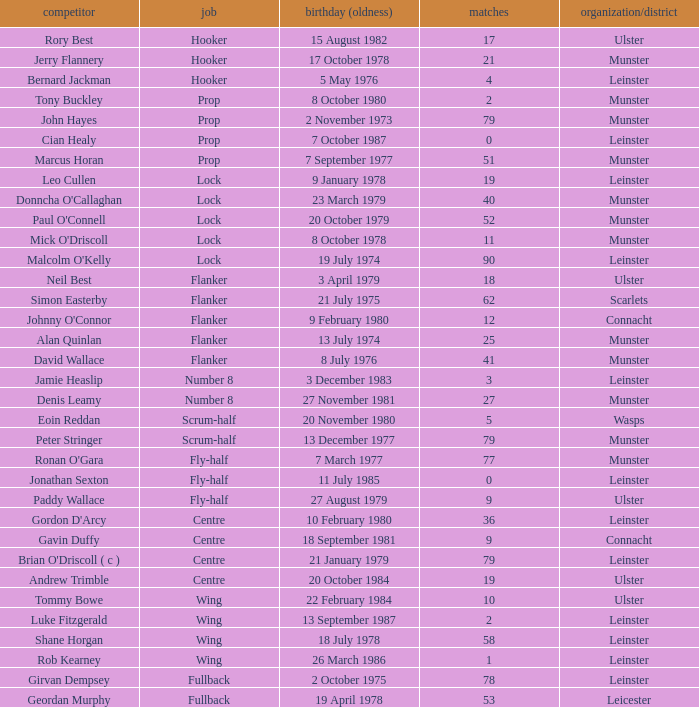Parse the table in full. {'header': ['competitor', 'job', 'birthday (oldness)', 'matches', 'organization/district'], 'rows': [['Rory Best', 'Hooker', '15 August 1982', '17', 'Ulster'], ['Jerry Flannery', 'Hooker', '17 October 1978', '21', 'Munster'], ['Bernard Jackman', 'Hooker', '5 May 1976', '4', 'Leinster'], ['Tony Buckley', 'Prop', '8 October 1980', '2', 'Munster'], ['John Hayes', 'Prop', '2 November 1973', '79', 'Munster'], ['Cian Healy', 'Prop', '7 October 1987', '0', 'Leinster'], ['Marcus Horan', 'Prop', '7 September 1977', '51', 'Munster'], ['Leo Cullen', 'Lock', '9 January 1978', '19', 'Leinster'], ["Donncha O'Callaghan", 'Lock', '23 March 1979', '40', 'Munster'], ["Paul O'Connell", 'Lock', '20 October 1979', '52', 'Munster'], ["Mick O'Driscoll", 'Lock', '8 October 1978', '11', 'Munster'], ["Malcolm O'Kelly", 'Lock', '19 July 1974', '90', 'Leinster'], ['Neil Best', 'Flanker', '3 April 1979', '18', 'Ulster'], ['Simon Easterby', 'Flanker', '21 July 1975', '62', 'Scarlets'], ["Johnny O'Connor", 'Flanker', '9 February 1980', '12', 'Connacht'], ['Alan Quinlan', 'Flanker', '13 July 1974', '25', 'Munster'], ['David Wallace', 'Flanker', '8 July 1976', '41', 'Munster'], ['Jamie Heaslip', 'Number 8', '3 December 1983', '3', 'Leinster'], ['Denis Leamy', 'Number 8', '27 November 1981', '27', 'Munster'], ['Eoin Reddan', 'Scrum-half', '20 November 1980', '5', 'Wasps'], ['Peter Stringer', 'Scrum-half', '13 December 1977', '79', 'Munster'], ["Ronan O'Gara", 'Fly-half', '7 March 1977', '77', 'Munster'], ['Jonathan Sexton', 'Fly-half', '11 July 1985', '0', 'Leinster'], ['Paddy Wallace', 'Fly-half', '27 August 1979', '9', 'Ulster'], ["Gordon D'Arcy", 'Centre', '10 February 1980', '36', 'Leinster'], ['Gavin Duffy', 'Centre', '18 September 1981', '9', 'Connacht'], ["Brian O'Driscoll ( c )", 'Centre', '21 January 1979', '79', 'Leinster'], ['Andrew Trimble', 'Centre', '20 October 1984', '19', 'Ulster'], ['Tommy Bowe', 'Wing', '22 February 1984', '10', 'Ulster'], ['Luke Fitzgerald', 'Wing', '13 September 1987', '2', 'Leinster'], ['Shane Horgan', 'Wing', '18 July 1978', '58', 'Leinster'], ['Rob Kearney', 'Wing', '26 March 1986', '1', 'Leinster'], ['Girvan Dempsey', 'Fullback', '2 October 1975', '78', 'Leinster'], ['Geordan Murphy', 'Fullback', '19 April 1978', '53', 'Leicester']]} What Club/province have caps less than 2 and Jonathan Sexton as player? Leinster. 